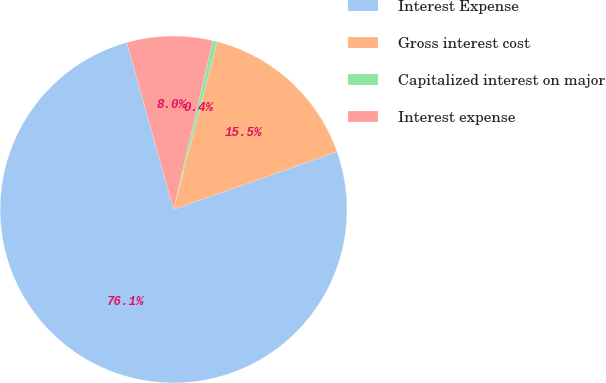Convert chart. <chart><loc_0><loc_0><loc_500><loc_500><pie_chart><fcel>Interest Expense<fcel>Gross interest cost<fcel>Capitalized interest on major<fcel>Interest expense<nl><fcel>76.06%<fcel>15.55%<fcel>0.42%<fcel>7.98%<nl></chart> 